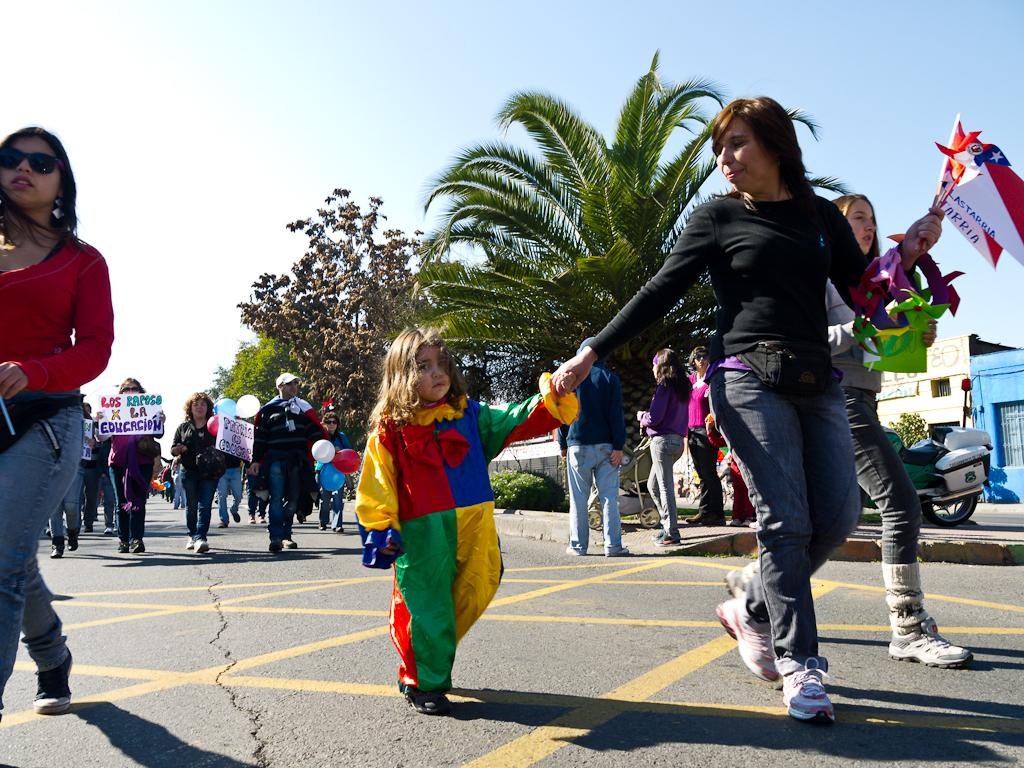What are the people in the image doing? The people in the image are walking. What can be seen in the image besides people? There are flags, banners, trees, buildings, and a motorcycle visible in the image. What is the sky's condition in the image? The sky is visible in the image. What type of government is depicted on the zebra in the image? There is no zebra present in the image, and therefore no government can be depicted on it. 